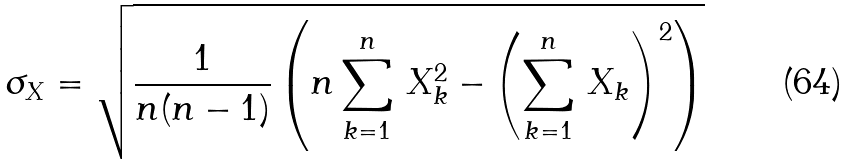<formula> <loc_0><loc_0><loc_500><loc_500>\sigma _ { X } = \sqrt { \frac { 1 } { n ( n - 1 ) } \left ( n \sum _ { k = 1 } ^ { n } \, X _ { k } ^ { 2 } - \left ( \sum _ { k = 1 } ^ { n } \, X _ { k } \right ) ^ { 2 } \right ) }</formula> 